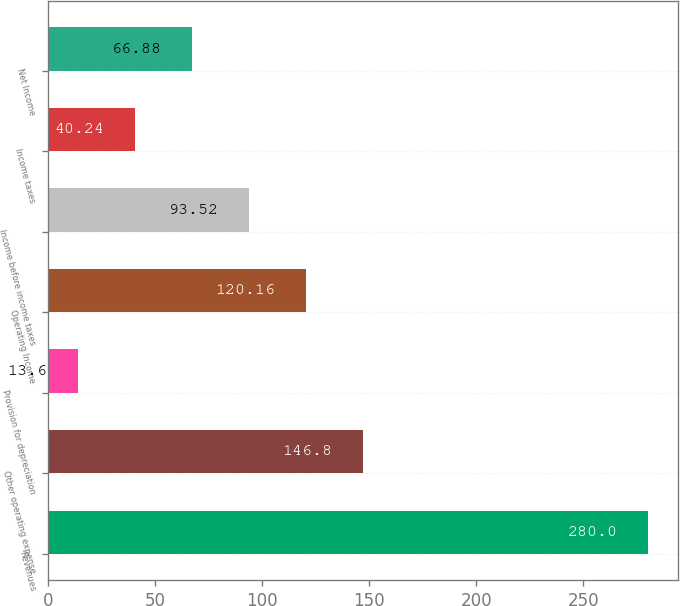Convert chart. <chart><loc_0><loc_0><loc_500><loc_500><bar_chart><fcel>Revenues<fcel>Other operating expense<fcel>Provision for depreciation<fcel>Operating Income<fcel>Income before income taxes<fcel>Income taxes<fcel>Net Income<nl><fcel>280<fcel>146.8<fcel>13.6<fcel>120.16<fcel>93.52<fcel>40.24<fcel>66.88<nl></chart> 